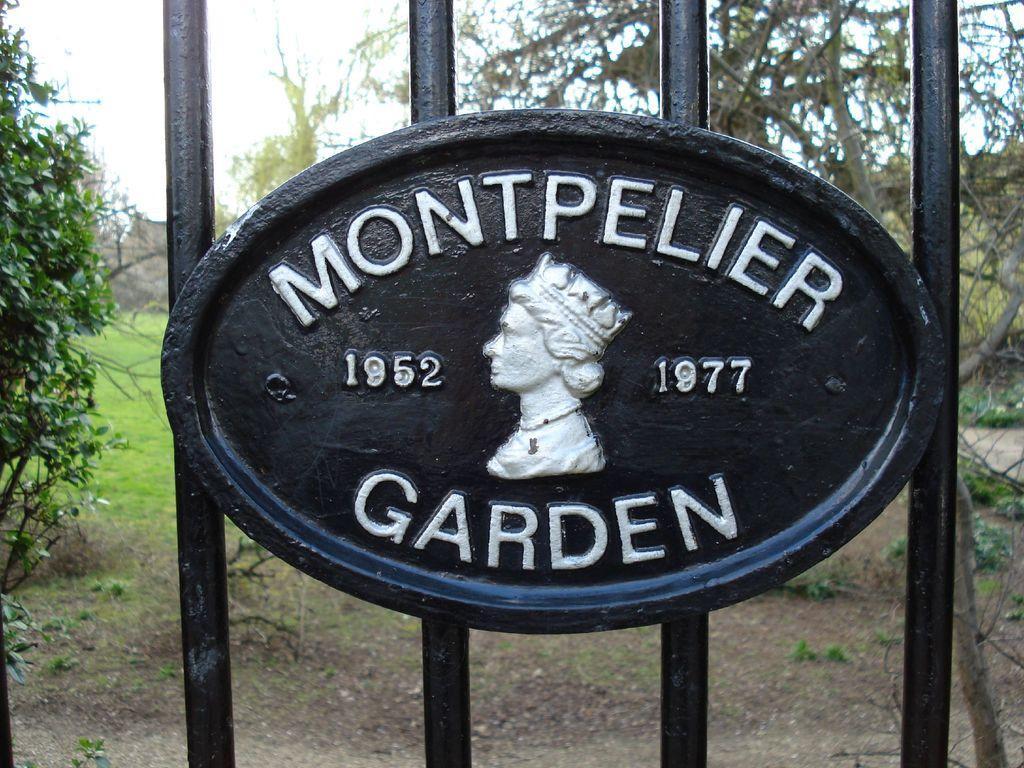How would you summarize this image in a sentence or two? In this image I can see few black colour iron bars and here I can see something is written in white colour. In the background I can see few trees and grass ground. 